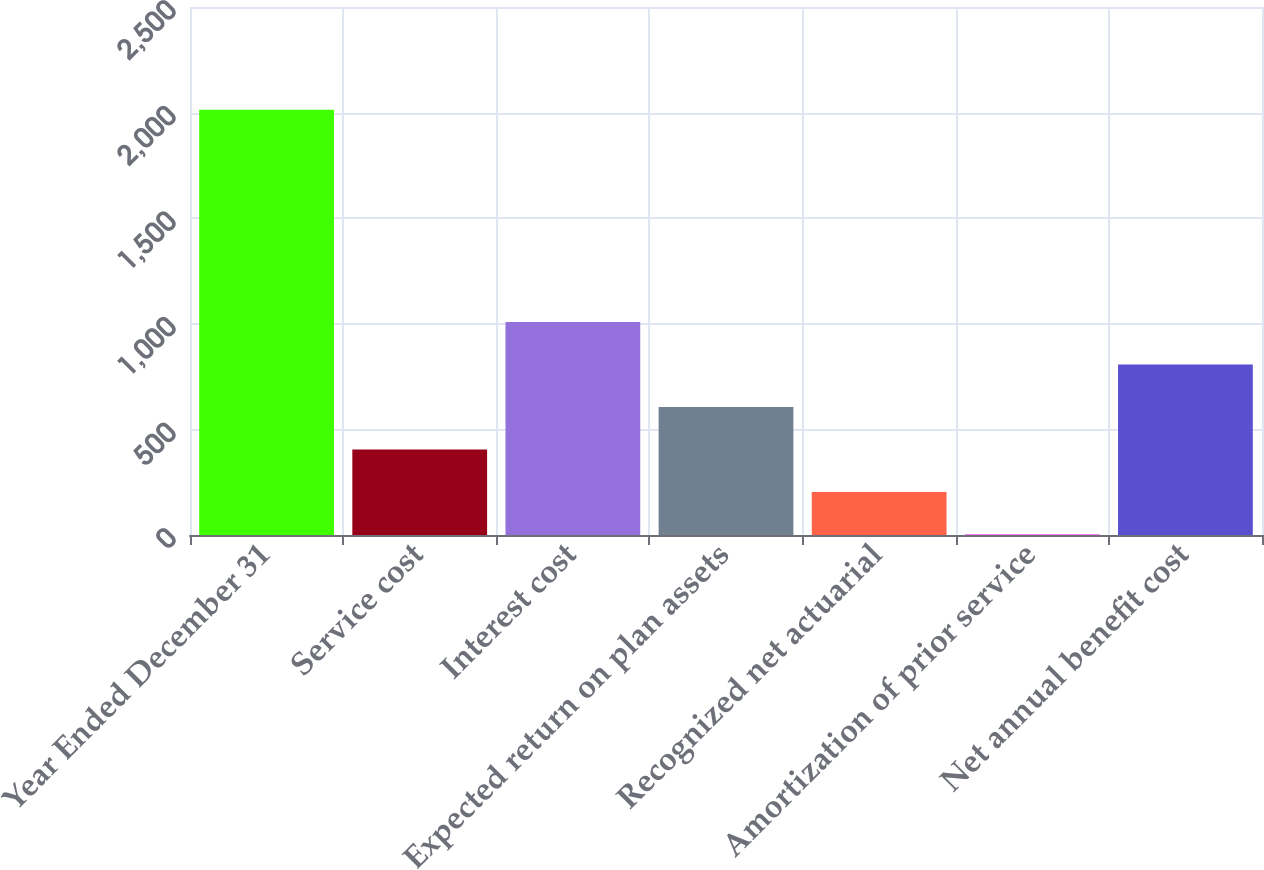Convert chart to OTSL. <chart><loc_0><loc_0><loc_500><loc_500><bar_chart><fcel>Year Ended December 31<fcel>Service cost<fcel>Interest cost<fcel>Expected return on plan assets<fcel>Recognized net actuarial<fcel>Amortization of prior service<fcel>Net annual benefit cost<nl><fcel>2014<fcel>404.4<fcel>1008<fcel>605.6<fcel>203.2<fcel>2<fcel>806.8<nl></chart> 